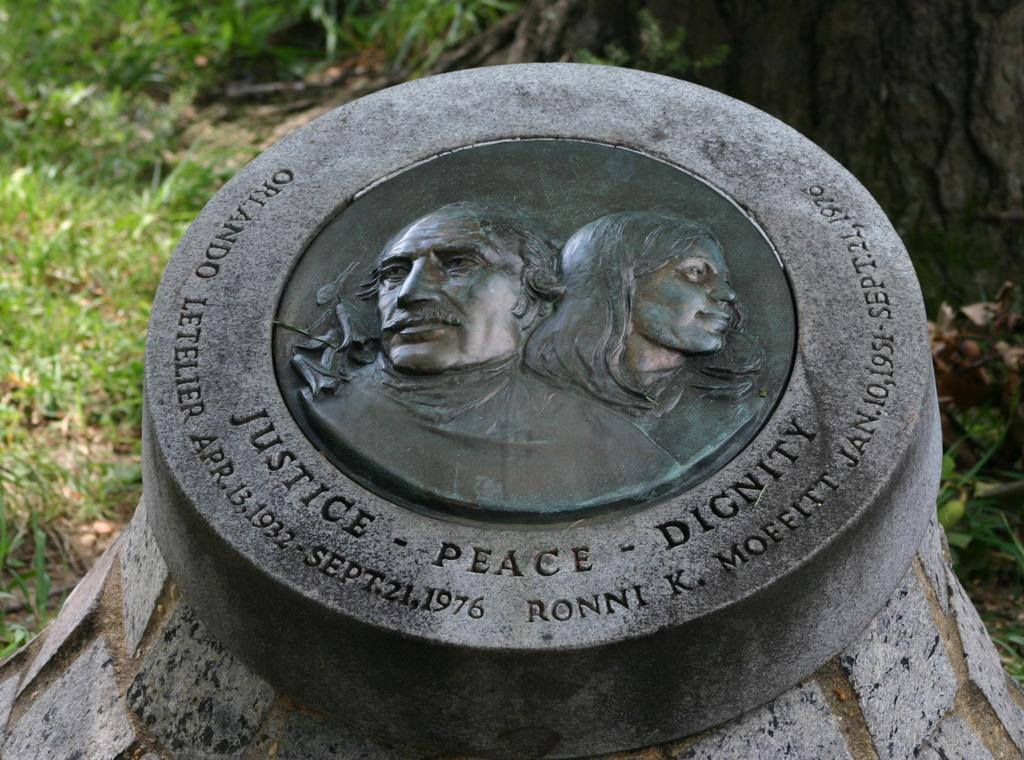What type of structure is depicted in the image? There is a stone gravity in the image. What is featured on the stone gravity? The stone gravity has a man and woman picture, and the phrase "Dignity, peace and Unity" is written on it. What type of natural environment is visible in the image? There is grass visible in the image. What unit of measurement is used to determine the friction between the man and woman picture on the stone gravity? There is no unit of measurement mentioned in the image, and friction is not a relevant concept in this context. 